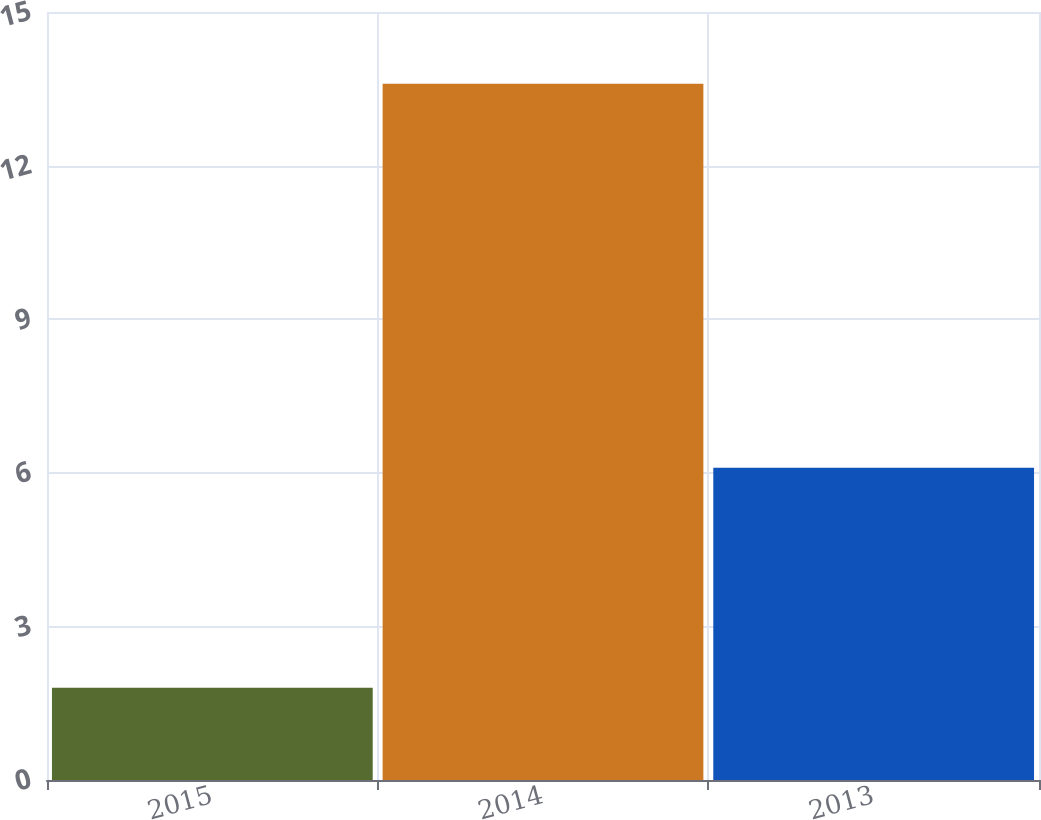Convert chart. <chart><loc_0><loc_0><loc_500><loc_500><bar_chart><fcel>2015<fcel>2014<fcel>2013<nl><fcel>1.8<fcel>13.6<fcel>6.1<nl></chart> 